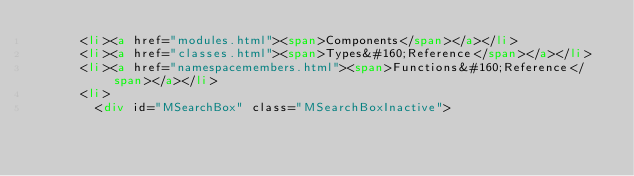Convert code to text. <code><loc_0><loc_0><loc_500><loc_500><_HTML_>      <li><a href="modules.html"><span>Components</span></a></li>
      <li><a href="classes.html"><span>Types&#160;Reference</span></a></li>
      <li><a href="namespacemembers.html"><span>Functions&#160;Reference</span></a></li>
      <li>
        <div id="MSearchBox" class="MSearchBoxInactive"></code> 